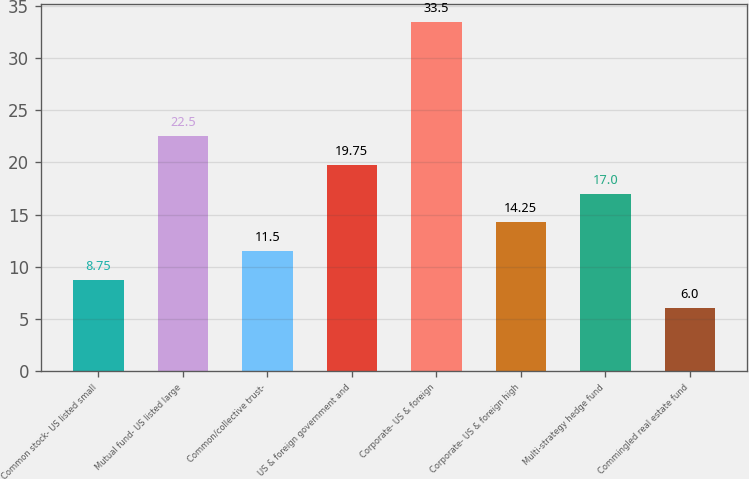Convert chart. <chart><loc_0><loc_0><loc_500><loc_500><bar_chart><fcel>Common stock- US listed small<fcel>Mutual fund- US listed large<fcel>Common/collective trust-<fcel>US & foreign government and<fcel>Corporate- US & foreign<fcel>Corporate- US & foreign high<fcel>Multi-strategy hedge fund<fcel>Commingled real estate fund<nl><fcel>8.75<fcel>22.5<fcel>11.5<fcel>19.75<fcel>33.5<fcel>14.25<fcel>17<fcel>6<nl></chart> 